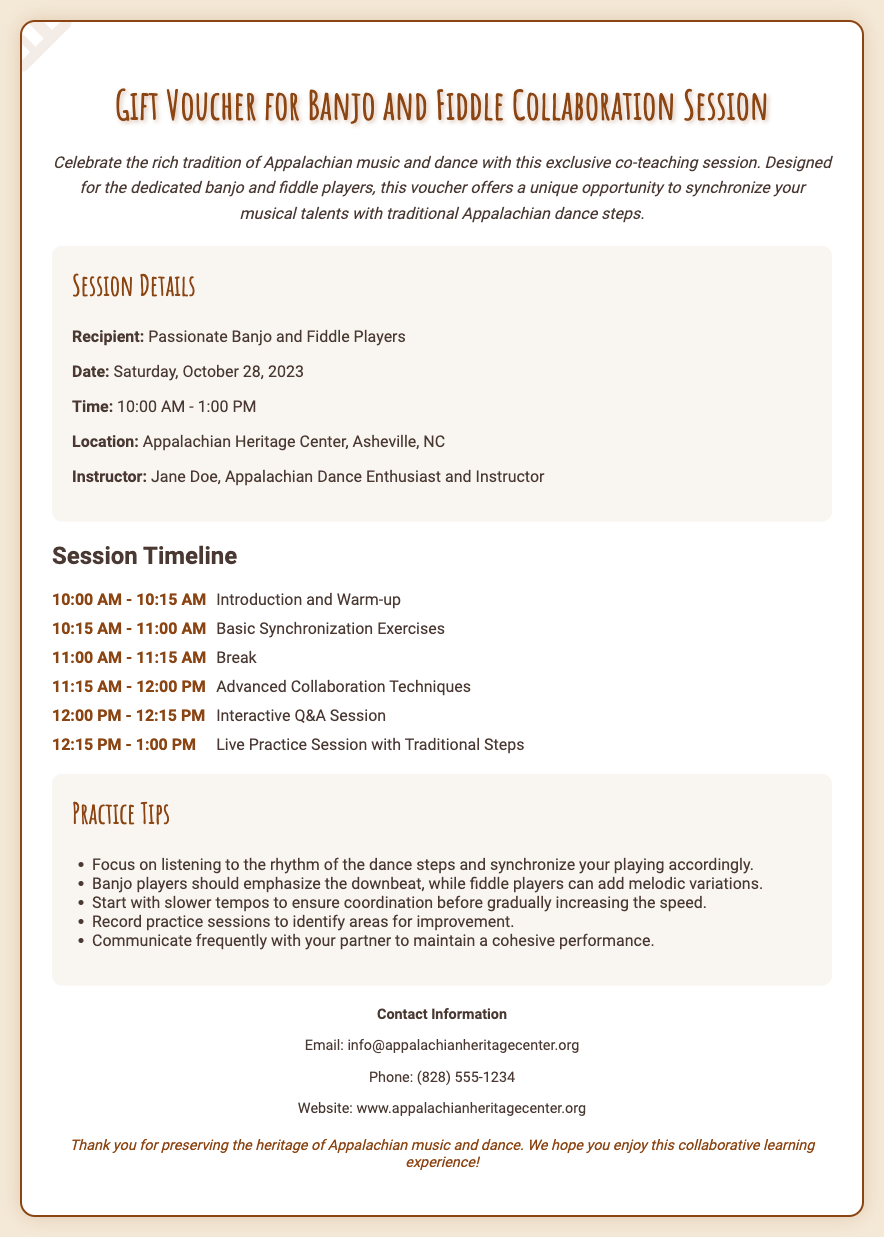What date is the session scheduled for? The date of the session is explicitly mentioned in the document under "Date."
Answer: Saturday, October 28, 2023 Who is the instructor for the session? The instructor's name is provided in the "Instructor" section of the details.
Answer: Jane Doe What time does the session begin? The starting time can be found under "Time" in the session details.
Answer: 10:00 AM What location is mentioned for the session? The location is specified clearly in the "Location" section.
Answer: Appalachian Heritage Center, Asheville, NC What are participants expected to focus on during practice? The practice tips section provides insights into what participants should emphasize.
Answer: Synchronize your playing accordingly What is the length of the live practice session? The timeline indicates the duration allocated for the live practice session.
Answer: 45 minutes What type of music is the session centered around? The introduction discusses the theme of the session, highlighting its focus.
Answer: Appalachian music and dance During which timeframe is the break scheduled? The timeline shows the specific time allocated for breaks during the session.
Answer: 11:00 AM - 11:15 AM What type of collaborative techniques will be covered? The session outline mentions the level of exercises participants will engage in.
Answer: Advanced Collaboration Techniques 